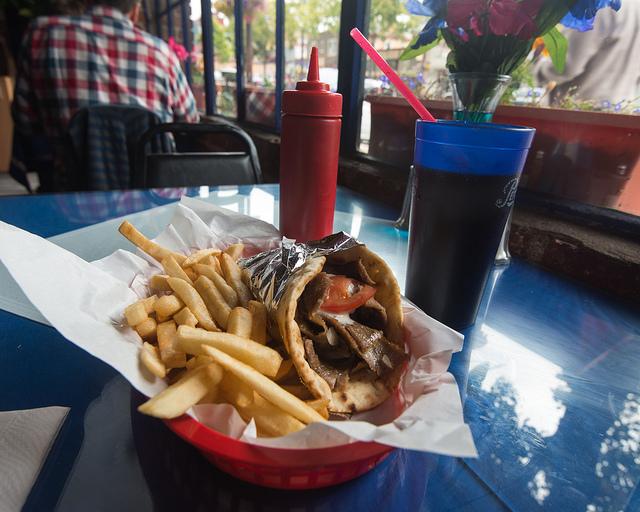What color is  the cup on the table?
Concise answer only. Blue. Where is the ketchup container?
Answer briefly. On table. What is being served?
Quick response, please. Gyro and fries. 